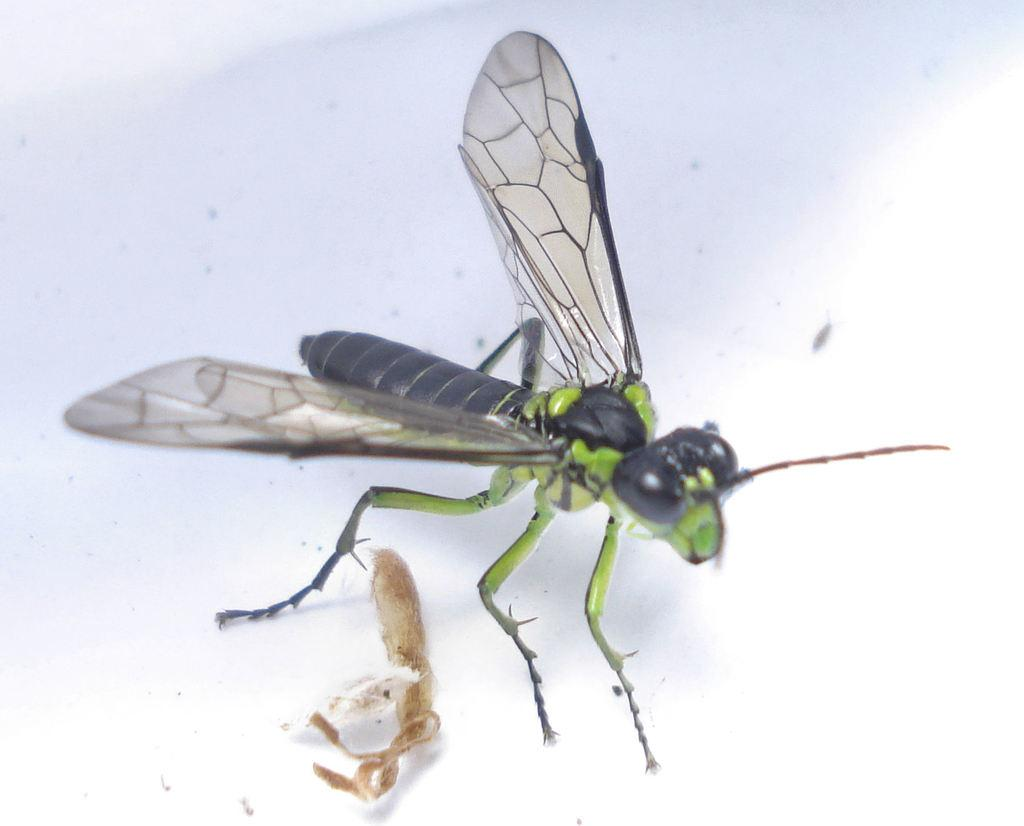What type of creature is in the picture? There is an insect in the picture. What are the main features of the insect? The insect has wings, a body, a head, and legs. What is the background or surface in the picture? There is a white surface in the picture. How does the insect carry its sack in the picture? There is no sack present in the image; the insect has wings, a body, a head, and legs. Is there any rain visible in the picture? There is no rain present in the image; it features an insect on a white surface. 